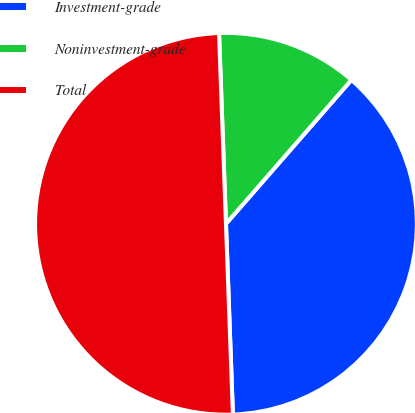Convert chart. <chart><loc_0><loc_0><loc_500><loc_500><pie_chart><fcel>Investment-grade<fcel>Noninvestment-grade<fcel>Total<nl><fcel>38.01%<fcel>11.99%<fcel>50.0%<nl></chart> 